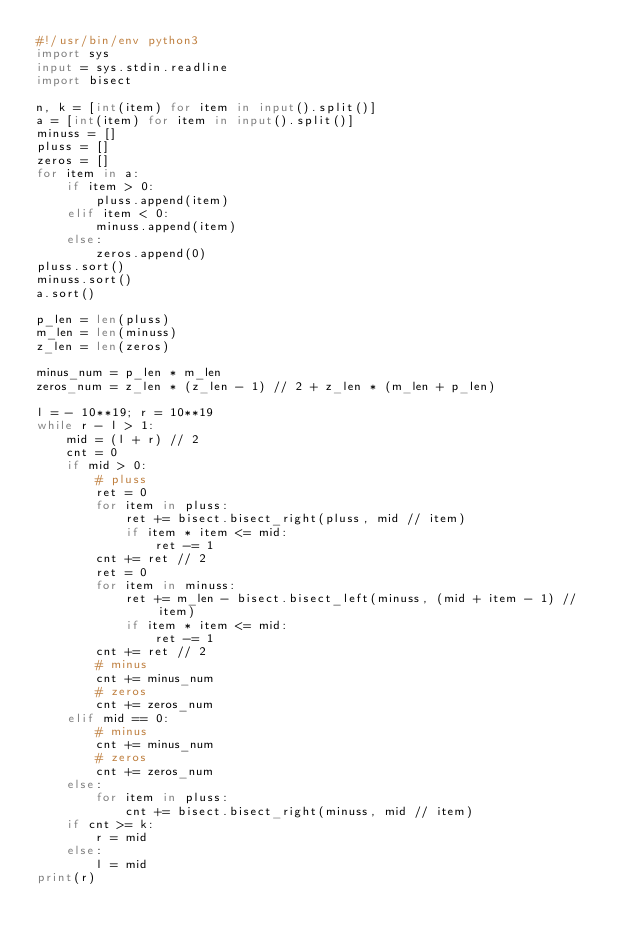Convert code to text. <code><loc_0><loc_0><loc_500><loc_500><_Python_>#!/usr/bin/env python3
import sys
input = sys.stdin.readline
import bisect

n, k = [int(item) for item in input().split()]
a = [int(item) for item in input().split()]
minuss = []
pluss = []
zeros = []
for item in a:
    if item > 0:
        pluss.append(item)
    elif item < 0:
        minuss.append(item)
    else:
        zeros.append(0)
pluss.sort()
minuss.sort()
a.sort()

p_len = len(pluss)
m_len = len(minuss)
z_len = len(zeros)

minus_num = p_len * m_len
zeros_num = z_len * (z_len - 1) // 2 + z_len * (m_len + p_len)

l = - 10**19; r = 10**19
while r - l > 1:
    mid = (l + r) // 2
    cnt = 0
    if mid > 0:
        # pluss
        ret = 0
        for item in pluss:
            ret += bisect.bisect_right(pluss, mid // item)
            if item * item <= mid:
                ret -= 1
        cnt += ret // 2
        ret = 0
        for item in minuss:
            ret += m_len - bisect.bisect_left(minuss, (mid + item - 1) // item)
            if item * item <= mid:
                ret -= 1
        cnt += ret // 2
        # minus
        cnt += minus_num
        # zeros
        cnt += zeros_num
    elif mid == 0:
        # minus
        cnt += minus_num
        # zeros
        cnt += zeros_num
    else:
        for item in pluss:
            cnt += bisect.bisect_right(minuss, mid // item)
    if cnt >= k:
        r = mid
    else:
        l = mid
print(r)</code> 